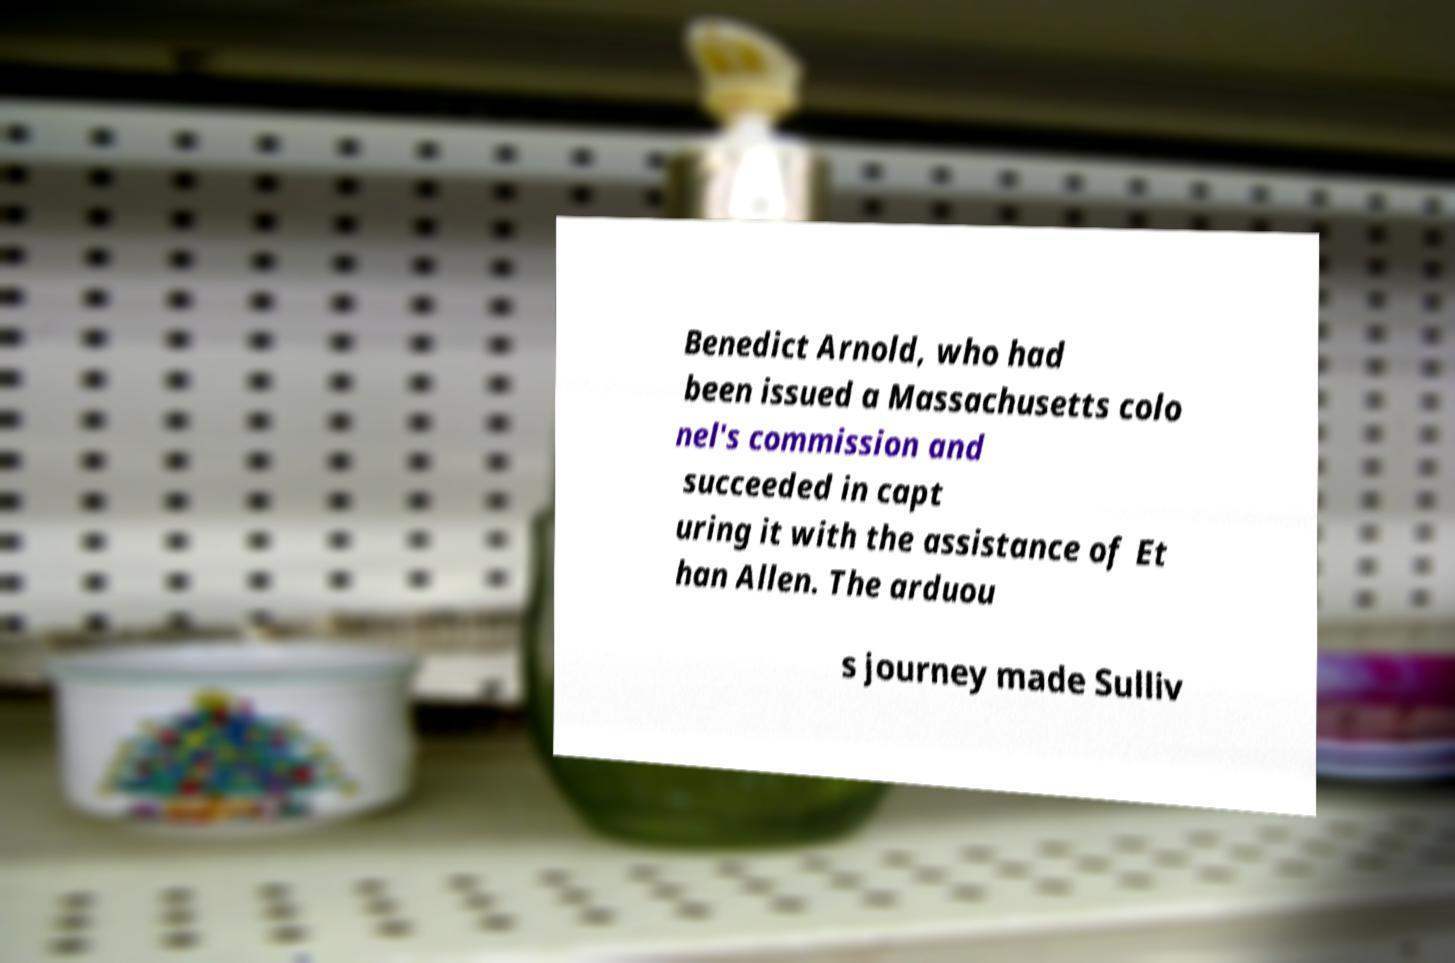What messages or text are displayed in this image? I need them in a readable, typed format. Benedict Arnold, who had been issued a Massachusetts colo nel's commission and succeeded in capt uring it with the assistance of Et han Allen. The arduou s journey made Sulliv 